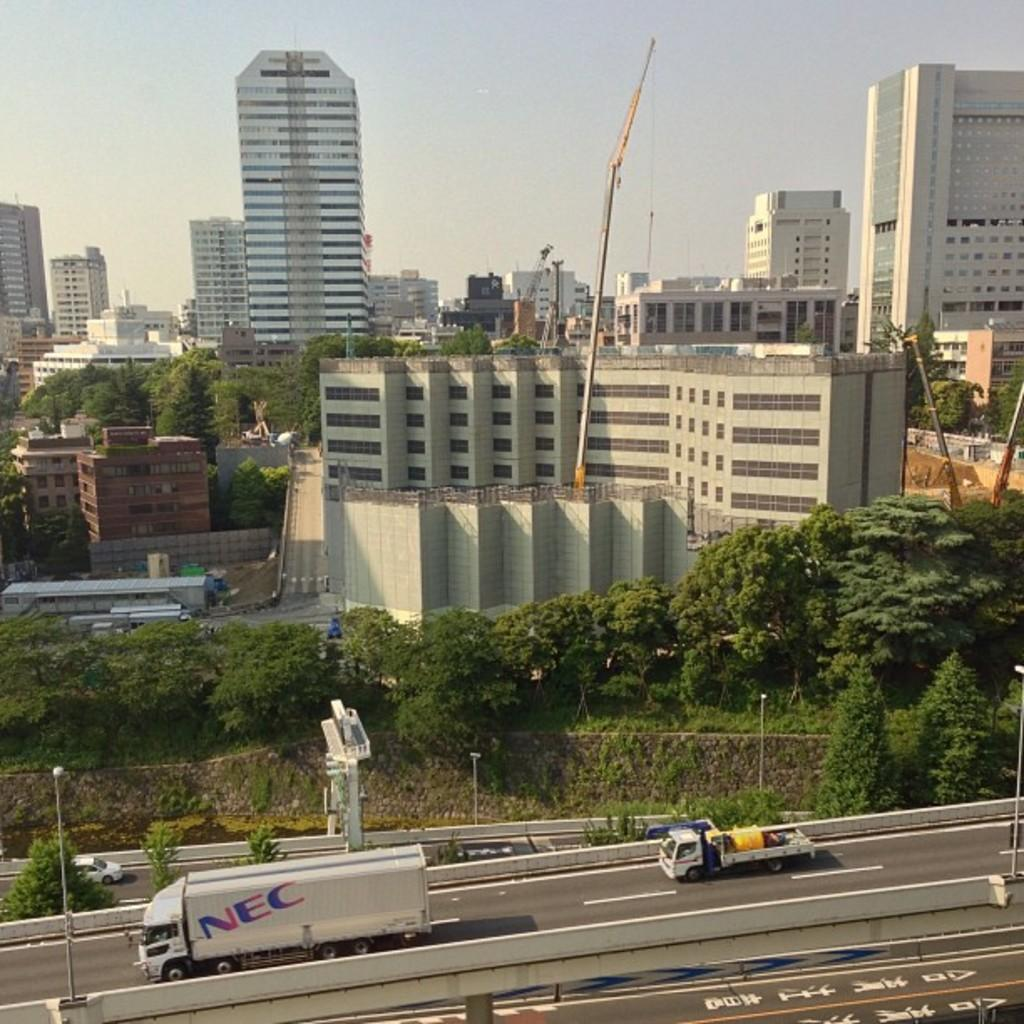What can be seen on the road in the image? There are many vehicles on the road in the image. What is present alongside the road in the image? There are poles on both sides of the road. What can be seen in the background of the image? There are many trees, buildings, and additional poles in the background of the image. What part of the natural environment is visible in the image? The sky is visible in the background of the image. What is the title of the coat worn by the person in the image? There is no person wearing a coat in the image. What country is depicted in the image? The image does not depict a specific country; it shows a road, vehicles, and other elements that could be found in various locations. 